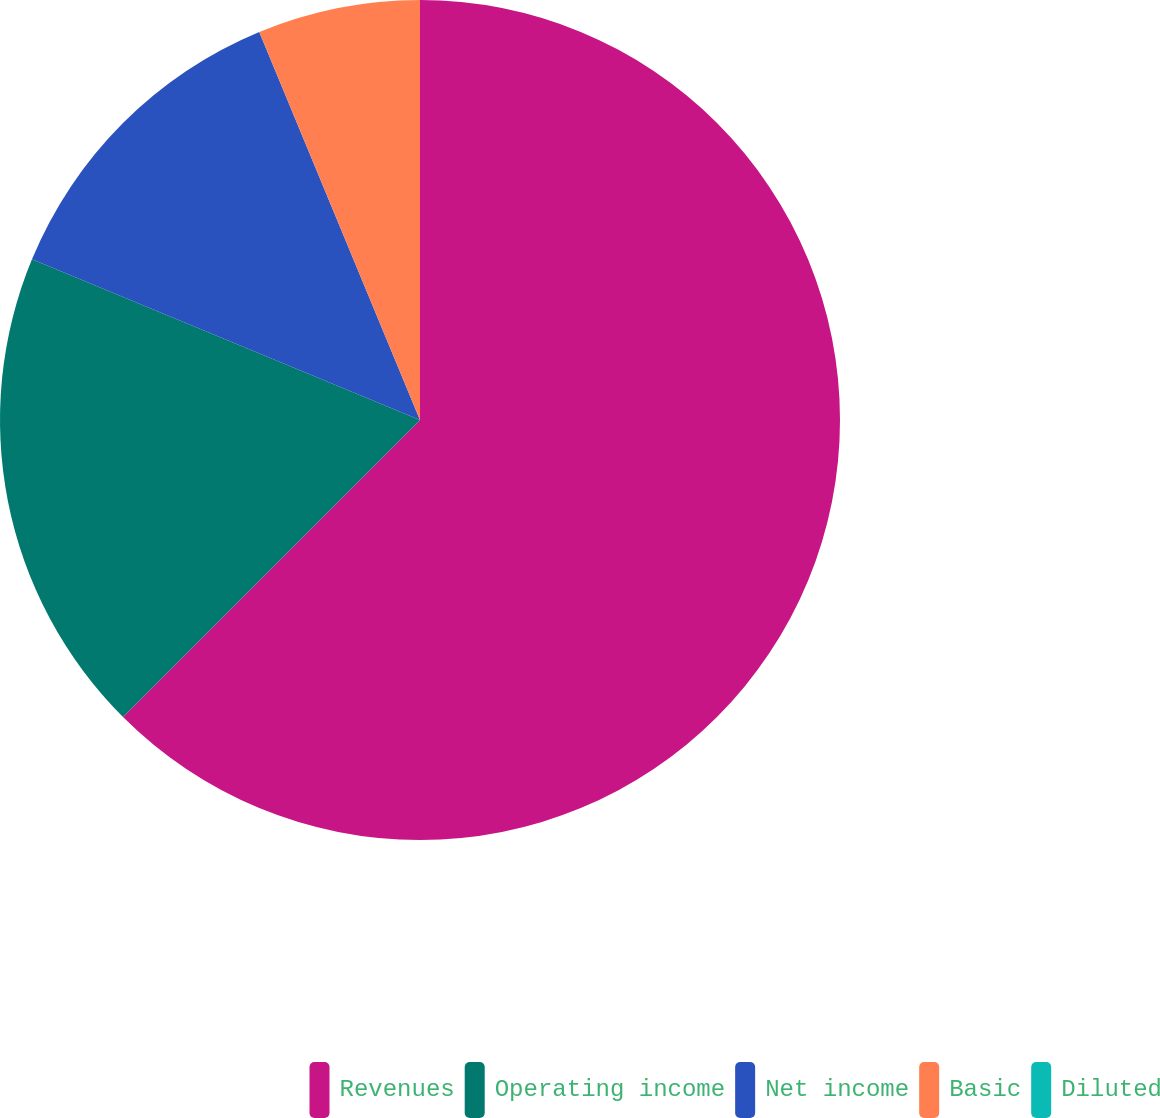Convert chart. <chart><loc_0><loc_0><loc_500><loc_500><pie_chart><fcel>Revenues<fcel>Operating income<fcel>Net income<fcel>Basic<fcel>Diluted<nl><fcel>62.5%<fcel>18.75%<fcel>12.5%<fcel>6.25%<fcel>0.0%<nl></chart> 